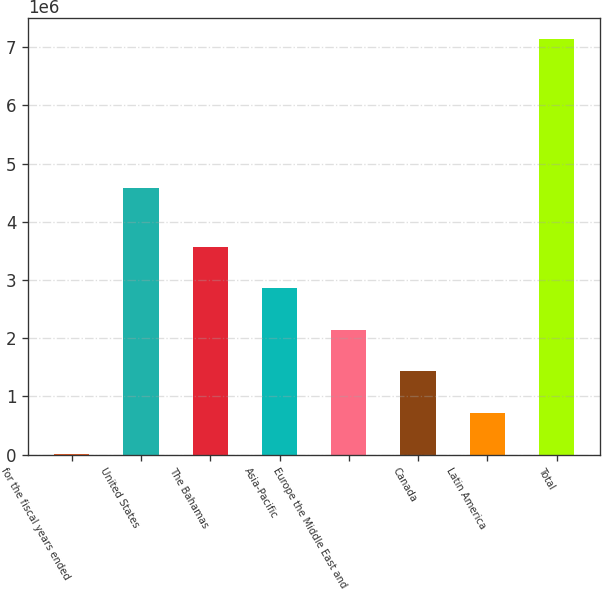Convert chart. <chart><loc_0><loc_0><loc_500><loc_500><bar_chart><fcel>for the fiscal years ended<fcel>United States<fcel>The Bahamas<fcel>Asia-Pacific<fcel>Europe the Middle East and<fcel>Canada<fcel>Latin America<fcel>Total<nl><fcel>2011<fcel>4.58941e+06<fcel>3.57102e+06<fcel>2.85722e+06<fcel>2.14342e+06<fcel>1.42962e+06<fcel>715814<fcel>7.14004e+06<nl></chart> 